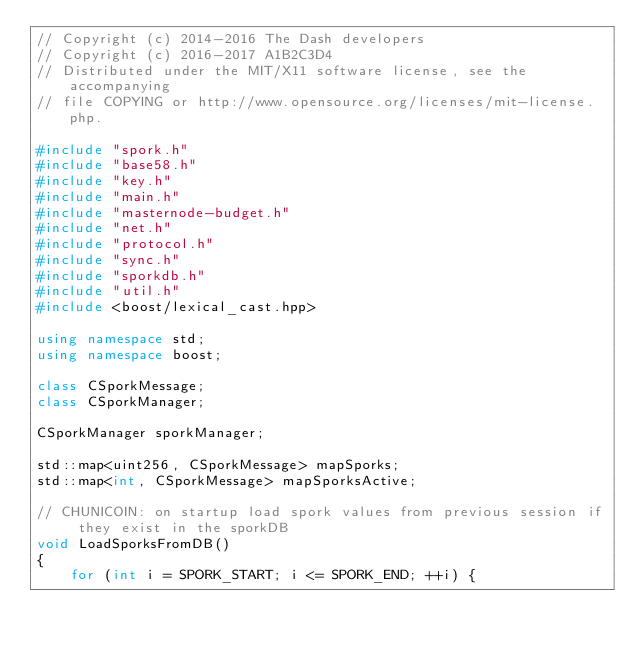Convert code to text. <code><loc_0><loc_0><loc_500><loc_500><_C++_>// Copyright (c) 2014-2016 The Dash developers
// Copyright (c) 2016-2017 A1B2C3D4
// Distributed under the MIT/X11 software license, see the accompanying
// file COPYING or http://www.opensource.org/licenses/mit-license.php.

#include "spork.h"
#include "base58.h"
#include "key.h"
#include "main.h"
#include "masternode-budget.h"
#include "net.h"
#include "protocol.h"
#include "sync.h"
#include "sporkdb.h"
#include "util.h"
#include <boost/lexical_cast.hpp>

using namespace std;
using namespace boost;

class CSporkMessage;
class CSporkManager;

CSporkManager sporkManager;

std::map<uint256, CSporkMessage> mapSporks;
std::map<int, CSporkMessage> mapSporksActive;

// CHUNICOIN: on startup load spork values from previous session if they exist in the sporkDB
void LoadSporksFromDB()
{
    for (int i = SPORK_START; i <= SPORK_END; ++i) {</code> 